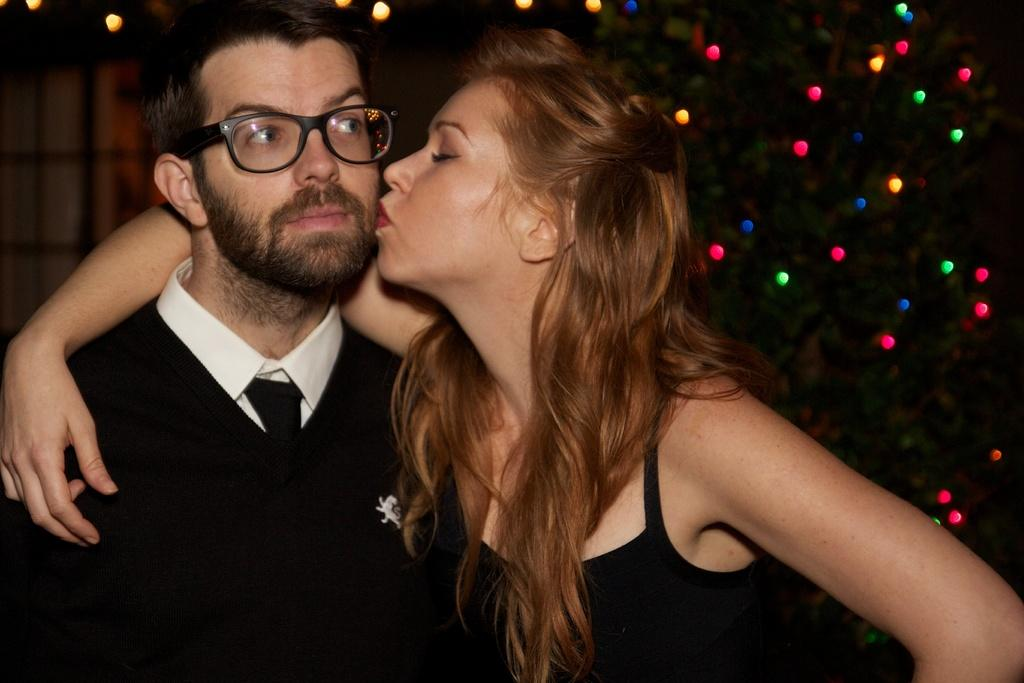How many people are present in the image? There are two people, a man and a woman, present in the image. What is the man wearing in the image? The man is wearing spectacles in the image. What can be seen in the background of the image? There are lights and a tree visible in the background of the image. What type of mitten is the woman wearing in the image? There is no mitten visible in the image; the woman is not wearing any gloves or mittens. Who is the owner of the tree in the background of the image? There is no information about the ownership of the tree in the image, and it is not possible to determine who the owner might be. 